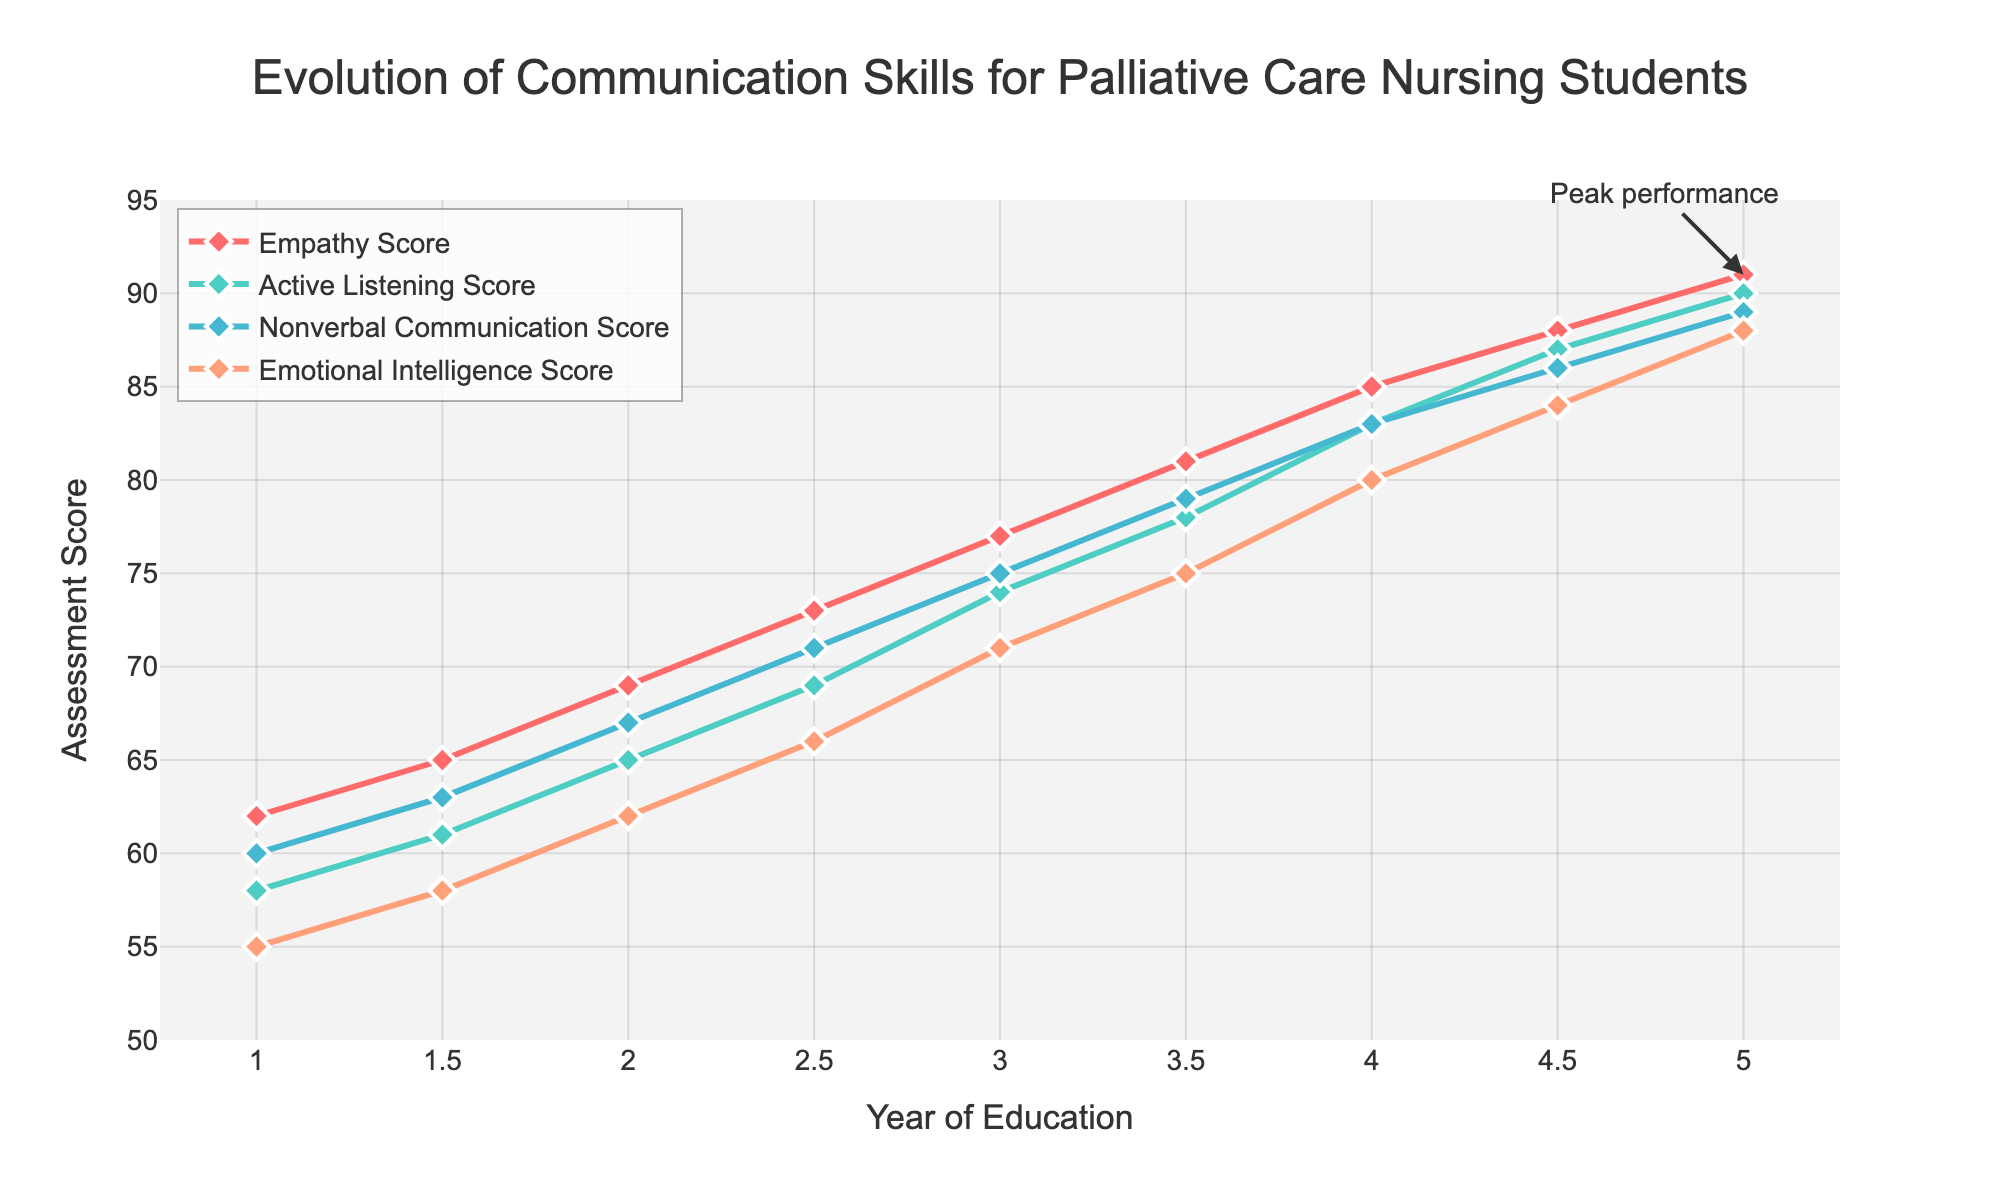What is the trend of the empathy scores over the years? The empathy scores increase steadily each year from an initial score of 62 in Year 1 to 91 in Year 5.
Answer: Increasing Which communication skill shows the highest score improvement from Year 1 to Year 5? All scores improve over time, but empathy scores increase the most, from 62 to 91, which is a difference of 29 points.
Answer: Empathy Score Compare the nonverbal communication scores at Year 2 and Year 4.5. How much do they differ? At Year 2, the nonverbal communication score is 67. At Year 4.5, it is 86. The difference is 86 - 67 = 19.
Answer: 19 points Between Year 3 and Year 4, which communication skill shows the greatest rate of improvement? Between Year 3 and Year 4, empathy scores increase from 77 to 85 (8 points), active listening scores from 74 to 83 (9 points), nonverbal communication scores from 75 to 83 (8 points), and emotional intelligence scores from 71 to 80 (9 points). Both Active Listening and Emotional Intelligence scores show the greatest rate of improvement.
Answer: Active Listening Score and Emotional Intelligence Score What is the peak performance score annotated in the figure? Which skill does it represent? The peak performance score annotated in the figure is 91, and it represents the empathy score in Year 5.
Answer: 91, Empathy Score What is the average active listening score over the entire period? Add all active listening scores: 58 + 61 + 65 + 69 + 74 + 78 + 83 + 87 + 90 = 665. Divide by the number of data points (9): 665 / 9 = 73.89.
Answer: 73.89 How does the rate of improvement differ between emotional intelligence scores and nonverbal communication scores from Year 1 to Year 5? Emotional intelligence scores increase from 55 to 88, a difference of 33 points. Nonverbal communication scores increase from 60 to 89, a difference of 29 points. Thus, the emotional intelligence scores show a larger overall improvement compared to nonverbal communication scores.
Answer: Emotional intelligence improves more by 4 points What visual change in the lines indicates Years 4 and 4.5 in the plot for all skills? The lines for all skills become steeper, indicating a sharper increase in scores during this period.
Answer: Steeper slopes How does the empathy score at Year 2.5 compare to the active listening score at Year 3? The empathy score at Year 2.5 is 73, while the active listening score at Year 3 is 74, making them almost equal, with active listening being slightly higher.
Answer: Empathy is 1 point lower What is the difference between the highest and lowest score of emotional intelligence over the years? The highest emotional intelligence score is 88 at Year 5, and the lowest is 55 at Year 1. The difference is 88 - 55 = 33.
Answer: 33 points 